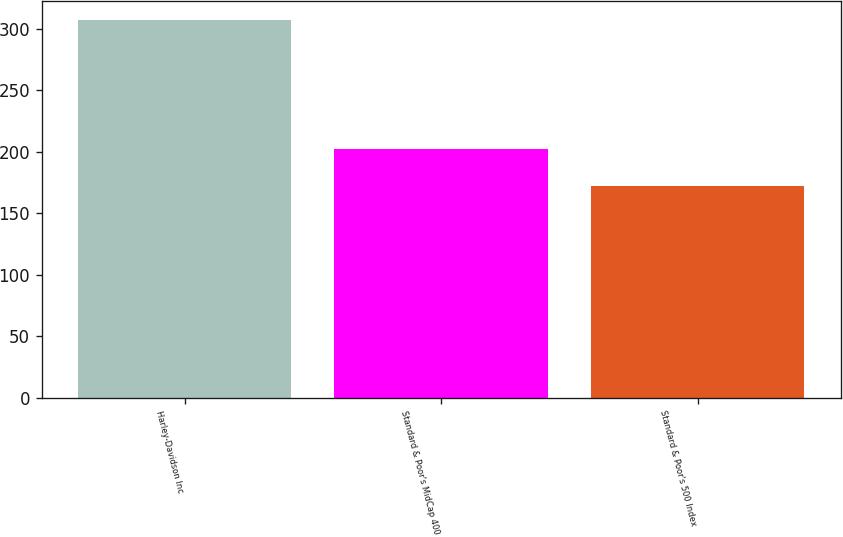<chart> <loc_0><loc_0><loc_500><loc_500><bar_chart><fcel>Harley-Davidson Inc<fcel>Standard & Poor's MidCap 400<fcel>Standard & Poor's 500 Index<nl><fcel>307<fcel>202<fcel>172<nl></chart> 